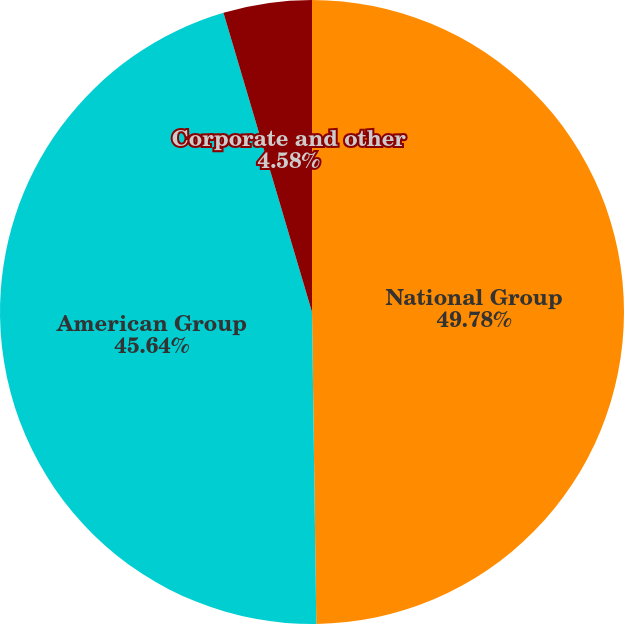<chart> <loc_0><loc_0><loc_500><loc_500><pie_chart><fcel>National Group<fcel>American Group<fcel>Corporate and other<nl><fcel>49.78%<fcel>45.64%<fcel>4.58%<nl></chart> 